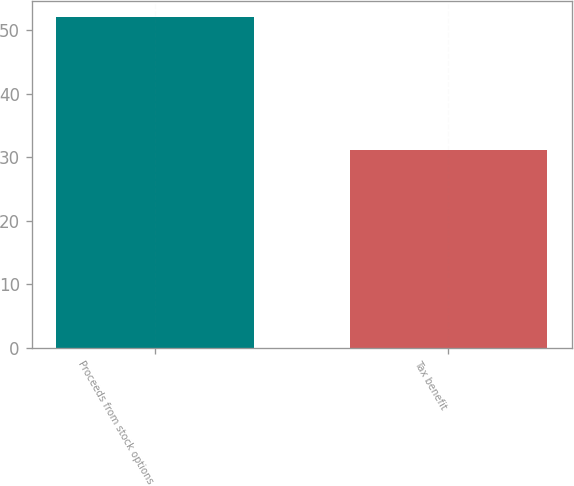Convert chart to OTSL. <chart><loc_0><loc_0><loc_500><loc_500><bar_chart><fcel>Proceeds from stock options<fcel>Tax benefit<nl><fcel>52<fcel>31.1<nl></chart> 